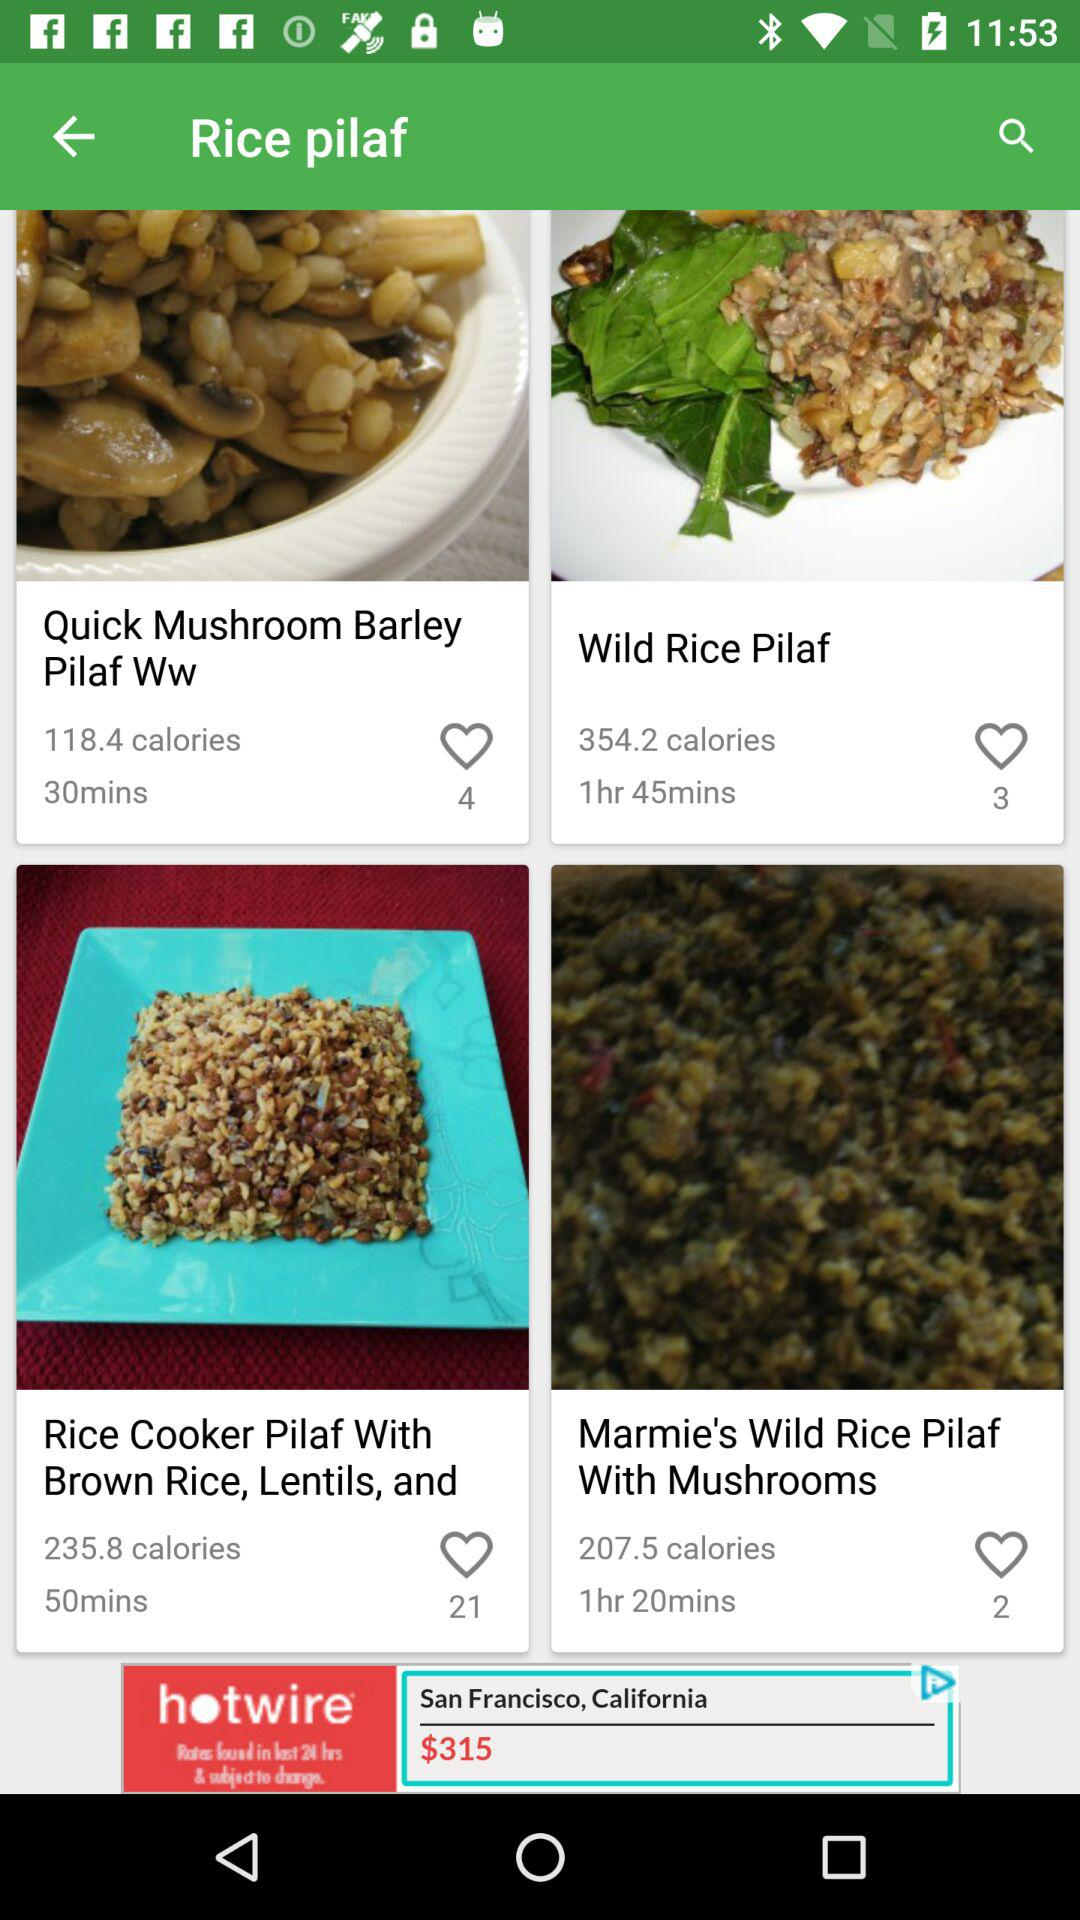What is the calorie count of "Quick Mushroom Barley Pilaf Ww"? The calorie count is 118.4 calories. 